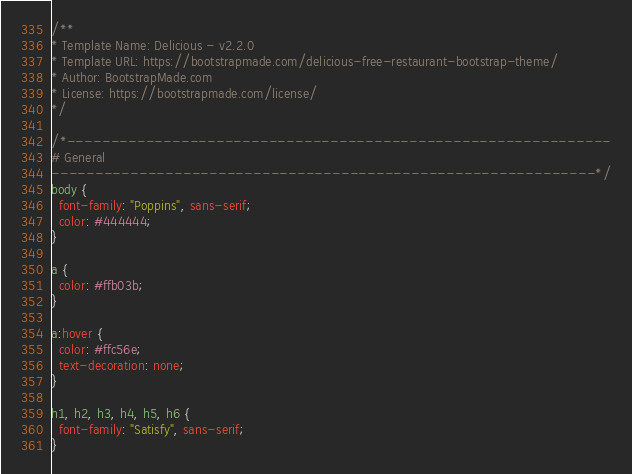Convert code to text. <code><loc_0><loc_0><loc_500><loc_500><_CSS_>/**
* Template Name: Delicious - v2.2.0
* Template URL: https://bootstrapmade.com/delicious-free-restaurant-bootstrap-theme/
* Author: BootstrapMade.com
* License: https://bootstrapmade.com/license/
*/

/*--------------------------------------------------------------
# General
--------------------------------------------------------------*/
body {
  font-family: "Poppins", sans-serif;
  color: #444444;
}

a {
  color: #ffb03b;
}

a:hover {
  color: #ffc56e;
  text-decoration: none;
}

h1, h2, h3, h4, h5, h6 {
  font-family: "Satisfy", sans-serif;
}
</code> 